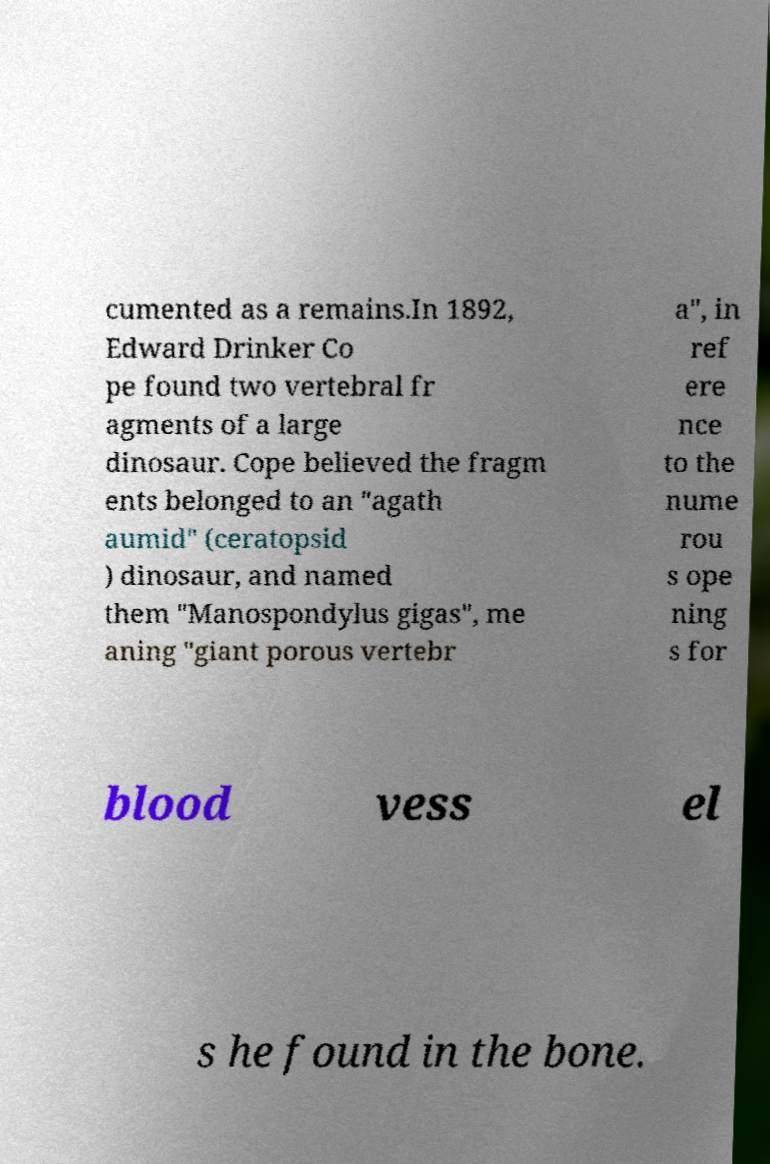There's text embedded in this image that I need extracted. Can you transcribe it verbatim? cumented as a remains.In 1892, Edward Drinker Co pe found two vertebral fr agments of a large dinosaur. Cope believed the fragm ents belonged to an "agath aumid" (ceratopsid ) dinosaur, and named them "Manospondylus gigas", me aning "giant porous vertebr a", in ref ere nce to the nume rou s ope ning s for blood vess el s he found in the bone. 